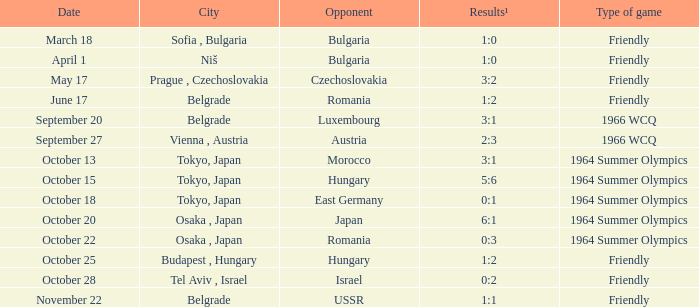What was the result for the 1964 summer olympics on october 18? 0:1. 